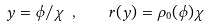<formula> <loc_0><loc_0><loc_500><loc_500>y = \phi / \chi \ , \quad r ( y ) = \rho _ { 0 } ( \phi ) { \chi }</formula> 